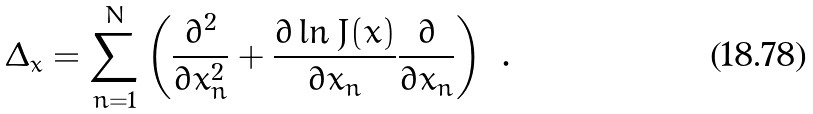Convert formula to latex. <formula><loc_0><loc_0><loc_500><loc_500>\Delta _ { x } = \sum _ { n = 1 } ^ { N } \left ( \frac { \partial ^ { 2 } } { \partial x ^ { 2 } _ { n } } + \frac { \partial \ln J ( x ) } { \partial x _ { n } } \frac { \partial } { \partial x _ { n } } \right ) \ .</formula> 